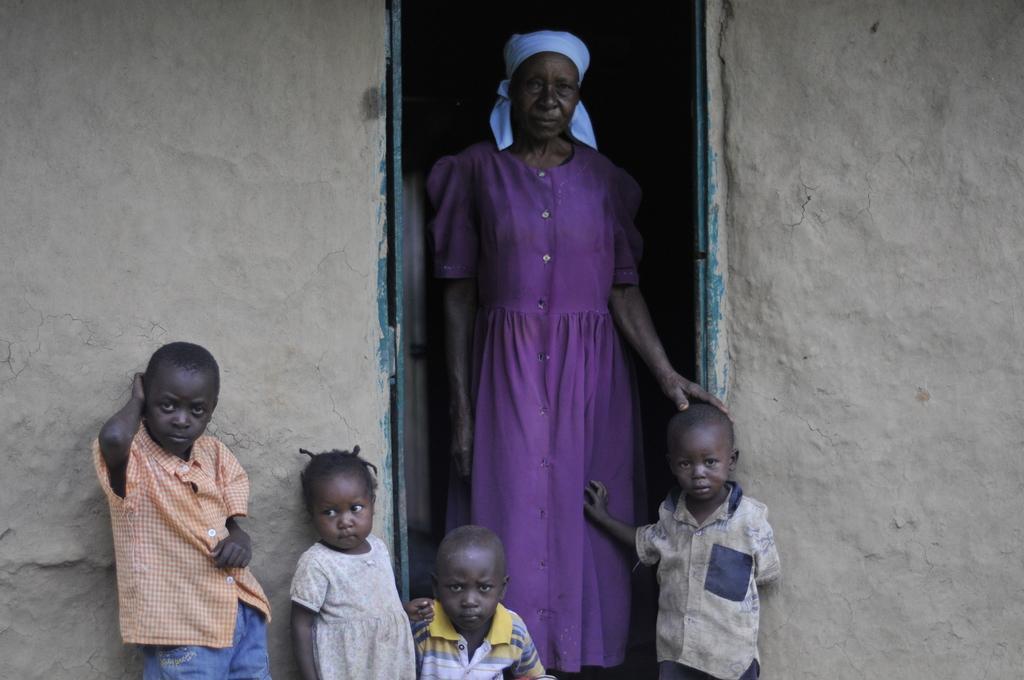Describe this image in one or two sentences. In this image in the center there is one woman standing, and also there are some children and there is a house. 